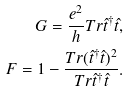<formula> <loc_0><loc_0><loc_500><loc_500>G = \frac { e ^ { 2 } } { h } T r \hat { t } ^ { \dagger } \hat { t } , \\ \quad F = 1 - \frac { T r ( \hat { t } ^ { \dagger } \hat { t } ) ^ { 2 } } { T r \hat { t } ^ { \dagger } \hat { t } } .</formula> 